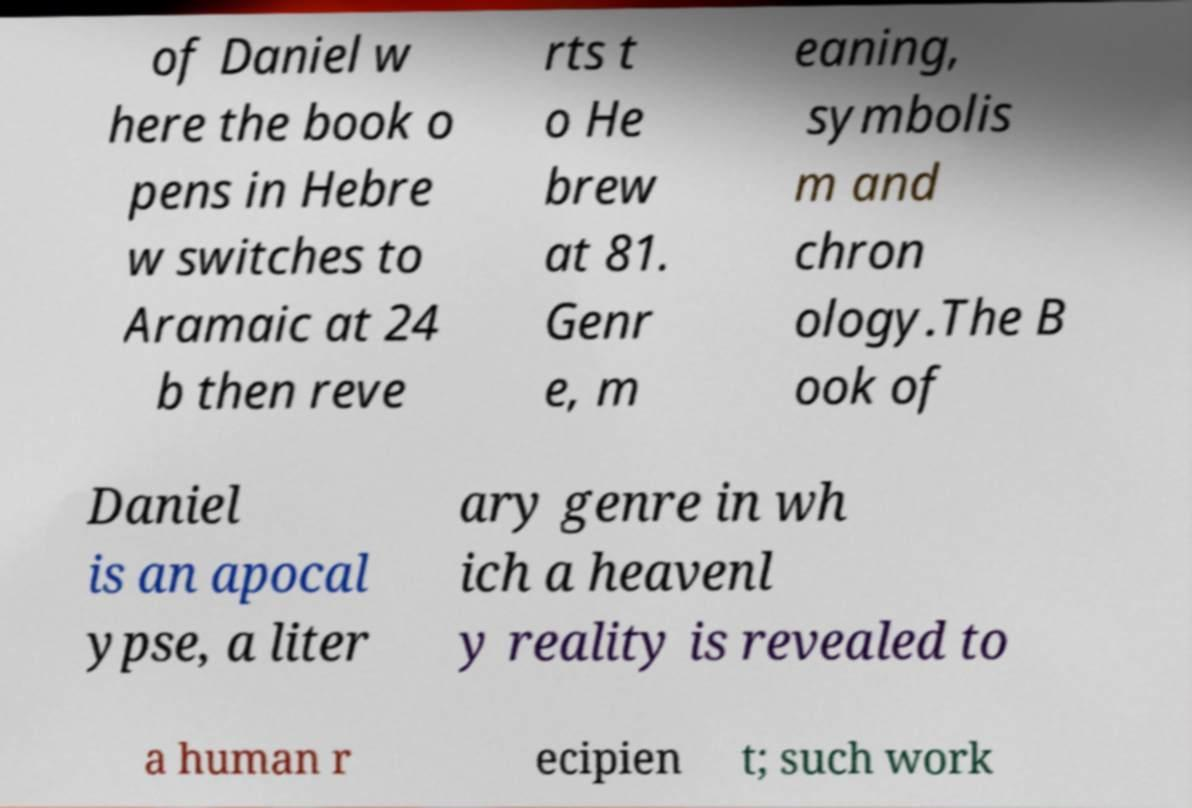What messages or text are displayed in this image? I need them in a readable, typed format. of Daniel w here the book o pens in Hebre w switches to Aramaic at 24 b then reve rts t o He brew at 81. Genr e, m eaning, symbolis m and chron ology.The B ook of Daniel is an apocal ypse, a liter ary genre in wh ich a heavenl y reality is revealed to a human r ecipien t; such work 